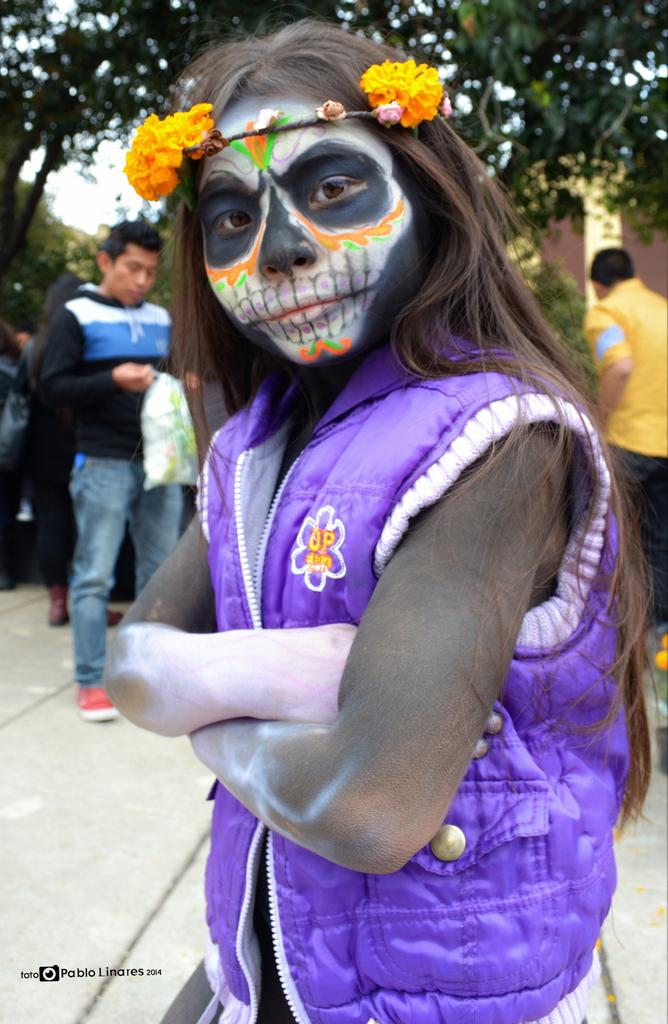What is the person in the foreground of the image wearing? The person in the image is wearing a costume. What can be seen in the background of the image? There are people, trees, and the sky visible in the background of the image. How many people are present in the image? There is one person in the foreground and at least some people in the background, but the exact number is not specified. What type of badge is the person wearing in the image? There is: There is no badge visible in the image. How does the person react to the argument happening in the background? There is no argument happening in the background of the image, so it is not possible to determine how the person would react. 